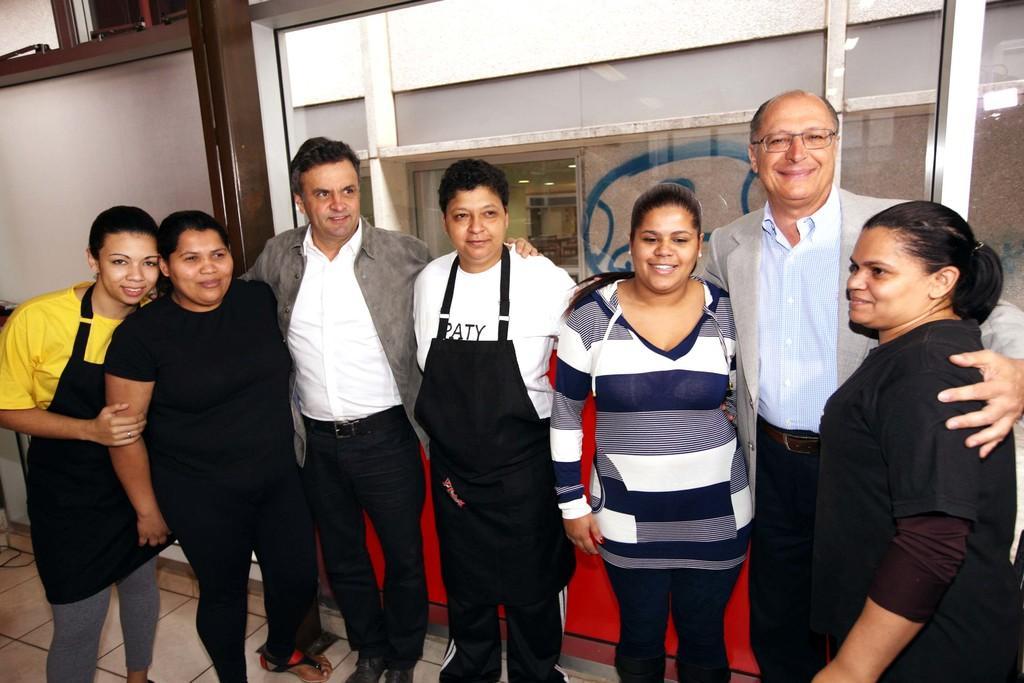Can you describe this image briefly? In the image in the center we can see few people were standing and they were smiling,which we can see on their faces. In the background there is a wall,glass,board and few other objects. 